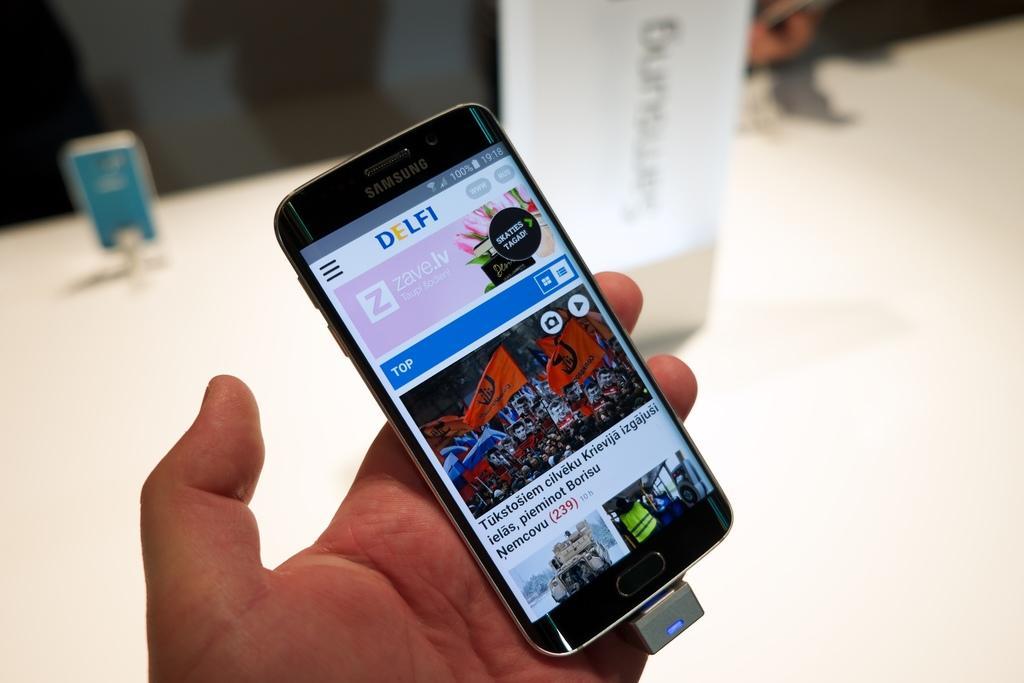Describe this image in one or two sentences. In the middle of the image, there is a hand of a person holding a mobile which is having a screen, in which there are images. And the background is blurred. 